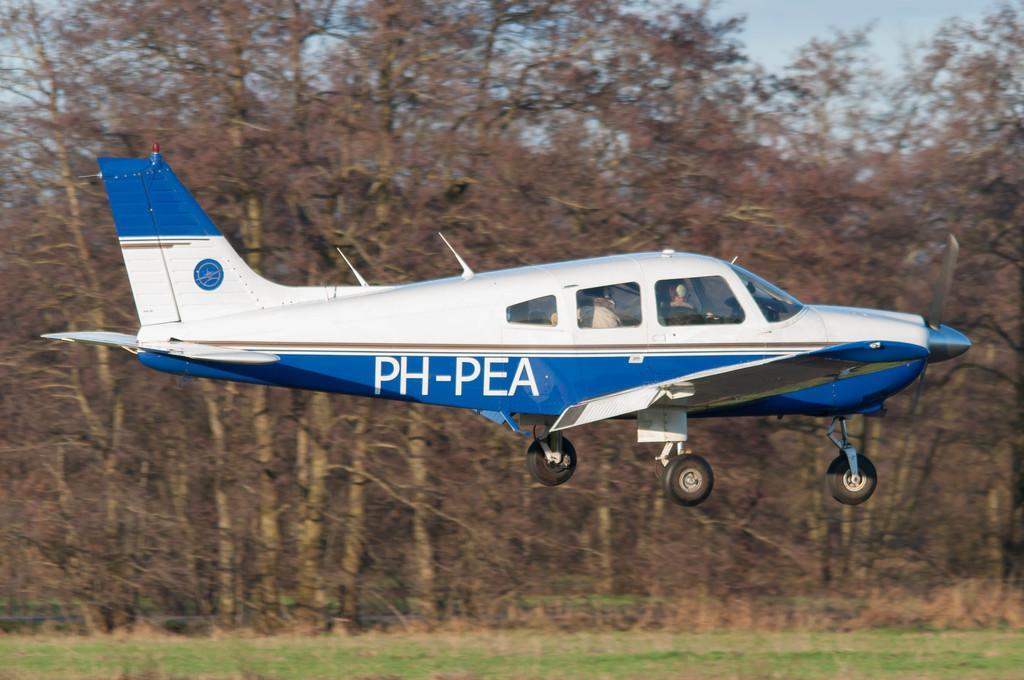In one or two sentences, can you explain what this image depicts? In this picture, in the middle, we can see an airplane flying in the air. In the airline, we can also see few persons sitting in it. In the background, we can see some trees. On the top, we can see a sky, at the bottom there is a grass. 